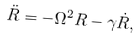<formula> <loc_0><loc_0><loc_500><loc_500>\ddot { R } = - \Omega ^ { 2 } R - \gamma \dot { R } ,</formula> 